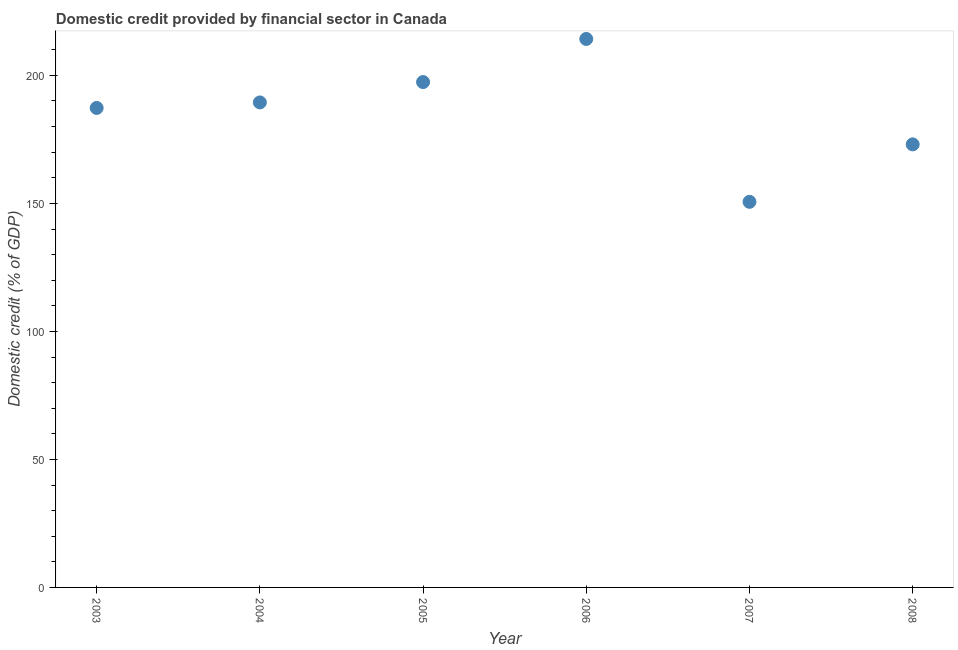What is the domestic credit provided by financial sector in 2007?
Your response must be concise. 150.62. Across all years, what is the maximum domestic credit provided by financial sector?
Provide a short and direct response. 214.23. Across all years, what is the minimum domestic credit provided by financial sector?
Your answer should be very brief. 150.62. What is the sum of the domestic credit provided by financial sector?
Offer a very short reply. 1112.02. What is the difference between the domestic credit provided by financial sector in 2005 and 2008?
Offer a very short reply. 24.34. What is the average domestic credit provided by financial sector per year?
Your answer should be compact. 185.34. What is the median domestic credit provided by financial sector?
Keep it short and to the point. 188.36. What is the ratio of the domestic credit provided by financial sector in 2003 to that in 2007?
Your answer should be very brief. 1.24. What is the difference between the highest and the second highest domestic credit provided by financial sector?
Your response must be concise. 16.83. What is the difference between the highest and the lowest domestic credit provided by financial sector?
Ensure brevity in your answer.  63.61. In how many years, is the domestic credit provided by financial sector greater than the average domestic credit provided by financial sector taken over all years?
Provide a succinct answer. 4. How many years are there in the graph?
Give a very brief answer. 6. What is the difference between two consecutive major ticks on the Y-axis?
Give a very brief answer. 50. Are the values on the major ticks of Y-axis written in scientific E-notation?
Offer a terse response. No. What is the title of the graph?
Make the answer very short. Domestic credit provided by financial sector in Canada. What is the label or title of the Y-axis?
Ensure brevity in your answer.  Domestic credit (% of GDP). What is the Domestic credit (% of GDP) in 2003?
Your answer should be compact. 187.29. What is the Domestic credit (% of GDP) in 2004?
Give a very brief answer. 189.44. What is the Domestic credit (% of GDP) in 2005?
Your answer should be compact. 197.4. What is the Domestic credit (% of GDP) in 2006?
Make the answer very short. 214.23. What is the Domestic credit (% of GDP) in 2007?
Provide a short and direct response. 150.62. What is the Domestic credit (% of GDP) in 2008?
Give a very brief answer. 173.05. What is the difference between the Domestic credit (% of GDP) in 2003 and 2004?
Keep it short and to the point. -2.15. What is the difference between the Domestic credit (% of GDP) in 2003 and 2005?
Your answer should be very brief. -10.11. What is the difference between the Domestic credit (% of GDP) in 2003 and 2006?
Keep it short and to the point. -26.94. What is the difference between the Domestic credit (% of GDP) in 2003 and 2007?
Your response must be concise. 36.67. What is the difference between the Domestic credit (% of GDP) in 2003 and 2008?
Your answer should be compact. 14.23. What is the difference between the Domestic credit (% of GDP) in 2004 and 2005?
Provide a short and direct response. -7.96. What is the difference between the Domestic credit (% of GDP) in 2004 and 2006?
Offer a terse response. -24.79. What is the difference between the Domestic credit (% of GDP) in 2004 and 2007?
Ensure brevity in your answer.  38.82. What is the difference between the Domestic credit (% of GDP) in 2004 and 2008?
Provide a succinct answer. 16.38. What is the difference between the Domestic credit (% of GDP) in 2005 and 2006?
Keep it short and to the point. -16.83. What is the difference between the Domestic credit (% of GDP) in 2005 and 2007?
Make the answer very short. 46.78. What is the difference between the Domestic credit (% of GDP) in 2005 and 2008?
Give a very brief answer. 24.34. What is the difference between the Domestic credit (% of GDP) in 2006 and 2007?
Offer a terse response. 63.61. What is the difference between the Domestic credit (% of GDP) in 2006 and 2008?
Offer a terse response. 41.17. What is the difference between the Domestic credit (% of GDP) in 2007 and 2008?
Ensure brevity in your answer.  -22.44. What is the ratio of the Domestic credit (% of GDP) in 2003 to that in 2005?
Provide a succinct answer. 0.95. What is the ratio of the Domestic credit (% of GDP) in 2003 to that in 2006?
Offer a very short reply. 0.87. What is the ratio of the Domestic credit (% of GDP) in 2003 to that in 2007?
Provide a short and direct response. 1.24. What is the ratio of the Domestic credit (% of GDP) in 2003 to that in 2008?
Offer a terse response. 1.08. What is the ratio of the Domestic credit (% of GDP) in 2004 to that in 2005?
Provide a short and direct response. 0.96. What is the ratio of the Domestic credit (% of GDP) in 2004 to that in 2006?
Make the answer very short. 0.88. What is the ratio of the Domestic credit (% of GDP) in 2004 to that in 2007?
Provide a short and direct response. 1.26. What is the ratio of the Domestic credit (% of GDP) in 2004 to that in 2008?
Your response must be concise. 1.09. What is the ratio of the Domestic credit (% of GDP) in 2005 to that in 2006?
Your answer should be very brief. 0.92. What is the ratio of the Domestic credit (% of GDP) in 2005 to that in 2007?
Your response must be concise. 1.31. What is the ratio of the Domestic credit (% of GDP) in 2005 to that in 2008?
Ensure brevity in your answer.  1.14. What is the ratio of the Domestic credit (% of GDP) in 2006 to that in 2007?
Make the answer very short. 1.42. What is the ratio of the Domestic credit (% of GDP) in 2006 to that in 2008?
Keep it short and to the point. 1.24. What is the ratio of the Domestic credit (% of GDP) in 2007 to that in 2008?
Provide a succinct answer. 0.87. 